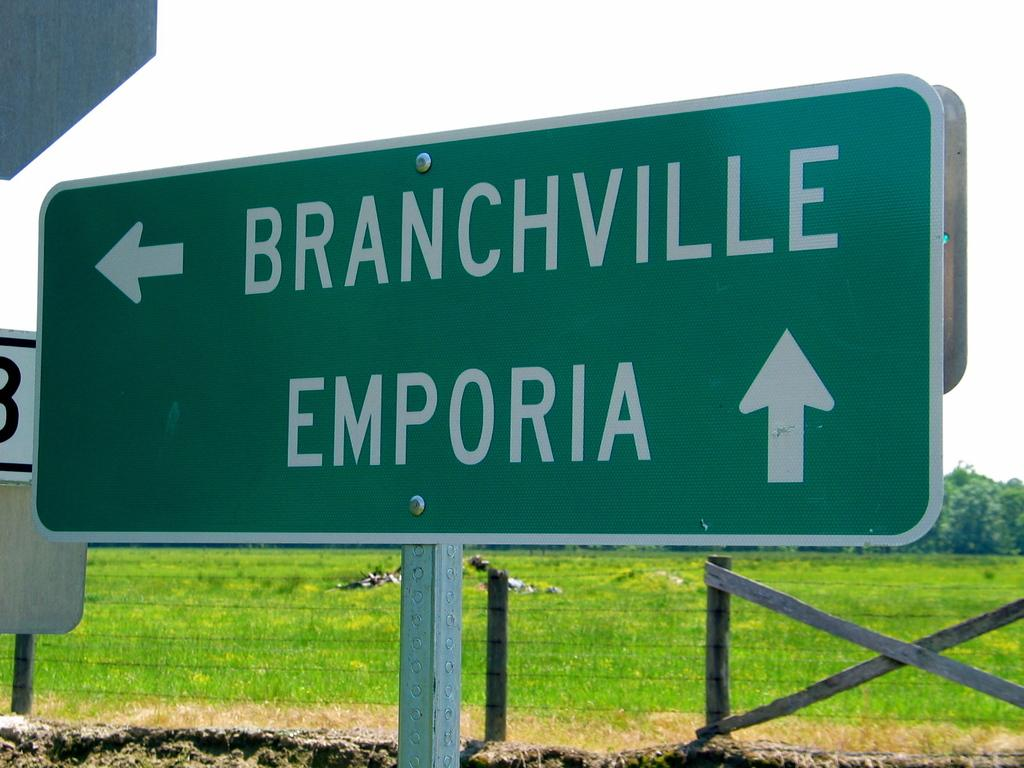Provide a one-sentence caption for the provided image. A street sign show that Emporia is ahead. 